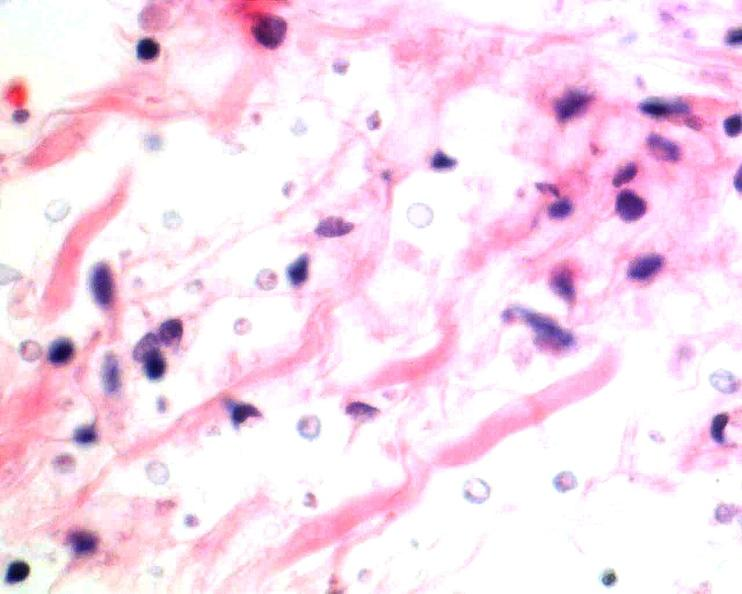s nervous present?
Answer the question using a single word or phrase. Yes 